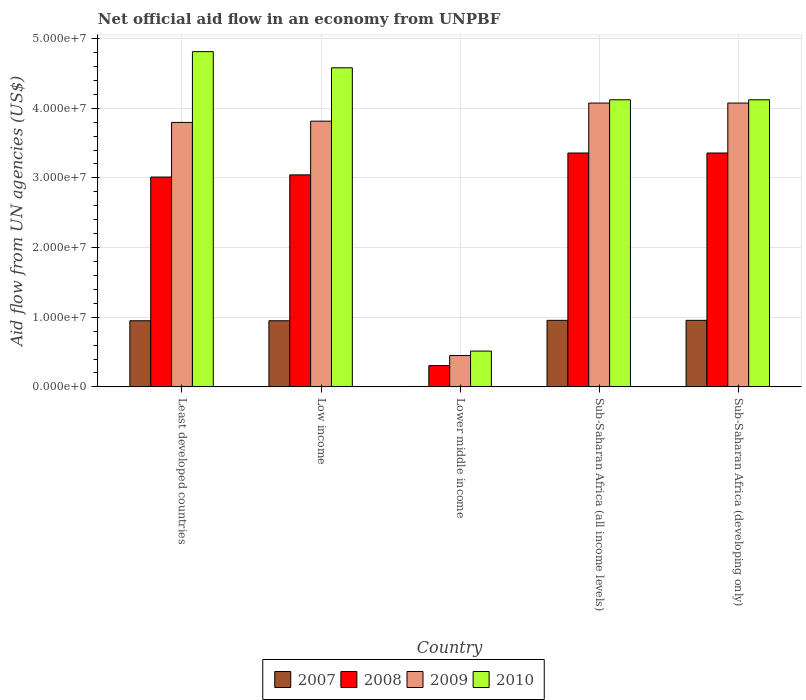How many groups of bars are there?
Keep it short and to the point. 5. What is the label of the 5th group of bars from the left?
Offer a very short reply. Sub-Saharan Africa (developing only). In how many cases, is the number of bars for a given country not equal to the number of legend labels?
Your response must be concise. 0. What is the net official aid flow in 2008 in Lower middle income?
Provide a short and direct response. 3.05e+06. Across all countries, what is the maximum net official aid flow in 2010?
Ensure brevity in your answer.  4.81e+07. Across all countries, what is the minimum net official aid flow in 2009?
Keep it short and to the point. 4.50e+06. In which country was the net official aid flow in 2007 maximum?
Offer a very short reply. Sub-Saharan Africa (all income levels). In which country was the net official aid flow in 2008 minimum?
Provide a succinct answer. Lower middle income. What is the total net official aid flow in 2009 in the graph?
Your answer should be compact. 1.62e+08. What is the difference between the net official aid flow in 2008 in Lower middle income and that in Sub-Saharan Africa (developing only)?
Your answer should be compact. -3.05e+07. What is the difference between the net official aid flow in 2007 in Low income and the net official aid flow in 2009 in Least developed countries?
Your answer should be compact. -2.85e+07. What is the average net official aid flow in 2008 per country?
Provide a succinct answer. 2.61e+07. What is the difference between the net official aid flow of/in 2010 and net official aid flow of/in 2009 in Least developed countries?
Make the answer very short. 1.02e+07. In how many countries, is the net official aid flow in 2009 greater than 26000000 US$?
Your answer should be compact. 4. What is the ratio of the net official aid flow in 2009 in Lower middle income to that in Sub-Saharan Africa (developing only)?
Give a very brief answer. 0.11. Is the difference between the net official aid flow in 2010 in Lower middle income and Sub-Saharan Africa (developing only) greater than the difference between the net official aid flow in 2009 in Lower middle income and Sub-Saharan Africa (developing only)?
Offer a very short reply. Yes. What is the difference between the highest and the second highest net official aid flow in 2008?
Keep it short and to the point. 3.14e+06. What is the difference between the highest and the lowest net official aid flow in 2010?
Offer a very short reply. 4.30e+07. In how many countries, is the net official aid flow in 2007 greater than the average net official aid flow in 2007 taken over all countries?
Offer a terse response. 4. What does the 2nd bar from the right in Low income represents?
Keep it short and to the point. 2009. What is the difference between two consecutive major ticks on the Y-axis?
Offer a very short reply. 1.00e+07. Does the graph contain any zero values?
Make the answer very short. No. How are the legend labels stacked?
Your response must be concise. Horizontal. What is the title of the graph?
Your response must be concise. Net official aid flow in an economy from UNPBF. What is the label or title of the Y-axis?
Ensure brevity in your answer.  Aid flow from UN agencies (US$). What is the Aid flow from UN agencies (US$) in 2007 in Least developed countries?
Give a very brief answer. 9.49e+06. What is the Aid flow from UN agencies (US$) in 2008 in Least developed countries?
Keep it short and to the point. 3.01e+07. What is the Aid flow from UN agencies (US$) in 2009 in Least developed countries?
Make the answer very short. 3.80e+07. What is the Aid flow from UN agencies (US$) in 2010 in Least developed countries?
Provide a short and direct response. 4.81e+07. What is the Aid flow from UN agencies (US$) in 2007 in Low income?
Your response must be concise. 9.49e+06. What is the Aid flow from UN agencies (US$) in 2008 in Low income?
Keep it short and to the point. 3.04e+07. What is the Aid flow from UN agencies (US$) of 2009 in Low income?
Offer a terse response. 3.81e+07. What is the Aid flow from UN agencies (US$) of 2010 in Low income?
Your answer should be very brief. 4.58e+07. What is the Aid flow from UN agencies (US$) of 2007 in Lower middle income?
Offer a very short reply. 6.00e+04. What is the Aid flow from UN agencies (US$) in 2008 in Lower middle income?
Give a very brief answer. 3.05e+06. What is the Aid flow from UN agencies (US$) in 2009 in Lower middle income?
Provide a succinct answer. 4.50e+06. What is the Aid flow from UN agencies (US$) in 2010 in Lower middle income?
Your response must be concise. 5.14e+06. What is the Aid flow from UN agencies (US$) in 2007 in Sub-Saharan Africa (all income levels)?
Ensure brevity in your answer.  9.55e+06. What is the Aid flow from UN agencies (US$) of 2008 in Sub-Saharan Africa (all income levels)?
Offer a terse response. 3.36e+07. What is the Aid flow from UN agencies (US$) of 2009 in Sub-Saharan Africa (all income levels)?
Make the answer very short. 4.07e+07. What is the Aid flow from UN agencies (US$) of 2010 in Sub-Saharan Africa (all income levels)?
Offer a terse response. 4.12e+07. What is the Aid flow from UN agencies (US$) of 2007 in Sub-Saharan Africa (developing only)?
Your response must be concise. 9.55e+06. What is the Aid flow from UN agencies (US$) in 2008 in Sub-Saharan Africa (developing only)?
Ensure brevity in your answer.  3.36e+07. What is the Aid flow from UN agencies (US$) in 2009 in Sub-Saharan Africa (developing only)?
Offer a terse response. 4.07e+07. What is the Aid flow from UN agencies (US$) of 2010 in Sub-Saharan Africa (developing only)?
Your answer should be compact. 4.12e+07. Across all countries, what is the maximum Aid flow from UN agencies (US$) of 2007?
Offer a terse response. 9.55e+06. Across all countries, what is the maximum Aid flow from UN agencies (US$) in 2008?
Make the answer very short. 3.36e+07. Across all countries, what is the maximum Aid flow from UN agencies (US$) of 2009?
Offer a terse response. 4.07e+07. Across all countries, what is the maximum Aid flow from UN agencies (US$) in 2010?
Make the answer very short. 4.81e+07. Across all countries, what is the minimum Aid flow from UN agencies (US$) of 2008?
Provide a succinct answer. 3.05e+06. Across all countries, what is the minimum Aid flow from UN agencies (US$) in 2009?
Provide a short and direct response. 4.50e+06. Across all countries, what is the minimum Aid flow from UN agencies (US$) of 2010?
Your response must be concise. 5.14e+06. What is the total Aid flow from UN agencies (US$) in 2007 in the graph?
Make the answer very short. 3.81e+07. What is the total Aid flow from UN agencies (US$) in 2008 in the graph?
Offer a very short reply. 1.31e+08. What is the total Aid flow from UN agencies (US$) in 2009 in the graph?
Offer a very short reply. 1.62e+08. What is the total Aid flow from UN agencies (US$) of 2010 in the graph?
Give a very brief answer. 1.81e+08. What is the difference between the Aid flow from UN agencies (US$) of 2007 in Least developed countries and that in Low income?
Your answer should be very brief. 0. What is the difference between the Aid flow from UN agencies (US$) in 2008 in Least developed countries and that in Low income?
Your answer should be very brief. -3.10e+05. What is the difference between the Aid flow from UN agencies (US$) in 2010 in Least developed countries and that in Low income?
Offer a very short reply. 2.32e+06. What is the difference between the Aid flow from UN agencies (US$) of 2007 in Least developed countries and that in Lower middle income?
Offer a very short reply. 9.43e+06. What is the difference between the Aid flow from UN agencies (US$) in 2008 in Least developed countries and that in Lower middle income?
Provide a succinct answer. 2.71e+07. What is the difference between the Aid flow from UN agencies (US$) in 2009 in Least developed countries and that in Lower middle income?
Your answer should be very brief. 3.35e+07. What is the difference between the Aid flow from UN agencies (US$) in 2010 in Least developed countries and that in Lower middle income?
Your answer should be very brief. 4.30e+07. What is the difference between the Aid flow from UN agencies (US$) in 2008 in Least developed countries and that in Sub-Saharan Africa (all income levels)?
Provide a short and direct response. -3.45e+06. What is the difference between the Aid flow from UN agencies (US$) in 2009 in Least developed countries and that in Sub-Saharan Africa (all income levels)?
Provide a short and direct response. -2.78e+06. What is the difference between the Aid flow from UN agencies (US$) of 2010 in Least developed countries and that in Sub-Saharan Africa (all income levels)?
Offer a terse response. 6.91e+06. What is the difference between the Aid flow from UN agencies (US$) of 2007 in Least developed countries and that in Sub-Saharan Africa (developing only)?
Keep it short and to the point. -6.00e+04. What is the difference between the Aid flow from UN agencies (US$) in 2008 in Least developed countries and that in Sub-Saharan Africa (developing only)?
Ensure brevity in your answer.  -3.45e+06. What is the difference between the Aid flow from UN agencies (US$) of 2009 in Least developed countries and that in Sub-Saharan Africa (developing only)?
Keep it short and to the point. -2.78e+06. What is the difference between the Aid flow from UN agencies (US$) in 2010 in Least developed countries and that in Sub-Saharan Africa (developing only)?
Your response must be concise. 6.91e+06. What is the difference between the Aid flow from UN agencies (US$) of 2007 in Low income and that in Lower middle income?
Give a very brief answer. 9.43e+06. What is the difference between the Aid flow from UN agencies (US$) in 2008 in Low income and that in Lower middle income?
Your response must be concise. 2.74e+07. What is the difference between the Aid flow from UN agencies (US$) in 2009 in Low income and that in Lower middle income?
Ensure brevity in your answer.  3.36e+07. What is the difference between the Aid flow from UN agencies (US$) in 2010 in Low income and that in Lower middle income?
Provide a succinct answer. 4.07e+07. What is the difference between the Aid flow from UN agencies (US$) of 2008 in Low income and that in Sub-Saharan Africa (all income levels)?
Your answer should be compact. -3.14e+06. What is the difference between the Aid flow from UN agencies (US$) of 2009 in Low income and that in Sub-Saharan Africa (all income levels)?
Keep it short and to the point. -2.60e+06. What is the difference between the Aid flow from UN agencies (US$) of 2010 in Low income and that in Sub-Saharan Africa (all income levels)?
Your answer should be very brief. 4.59e+06. What is the difference between the Aid flow from UN agencies (US$) in 2007 in Low income and that in Sub-Saharan Africa (developing only)?
Ensure brevity in your answer.  -6.00e+04. What is the difference between the Aid flow from UN agencies (US$) in 2008 in Low income and that in Sub-Saharan Africa (developing only)?
Provide a succinct answer. -3.14e+06. What is the difference between the Aid flow from UN agencies (US$) of 2009 in Low income and that in Sub-Saharan Africa (developing only)?
Offer a terse response. -2.60e+06. What is the difference between the Aid flow from UN agencies (US$) of 2010 in Low income and that in Sub-Saharan Africa (developing only)?
Your response must be concise. 4.59e+06. What is the difference between the Aid flow from UN agencies (US$) of 2007 in Lower middle income and that in Sub-Saharan Africa (all income levels)?
Provide a succinct answer. -9.49e+06. What is the difference between the Aid flow from UN agencies (US$) of 2008 in Lower middle income and that in Sub-Saharan Africa (all income levels)?
Offer a very short reply. -3.05e+07. What is the difference between the Aid flow from UN agencies (US$) of 2009 in Lower middle income and that in Sub-Saharan Africa (all income levels)?
Give a very brief answer. -3.62e+07. What is the difference between the Aid flow from UN agencies (US$) in 2010 in Lower middle income and that in Sub-Saharan Africa (all income levels)?
Offer a terse response. -3.61e+07. What is the difference between the Aid flow from UN agencies (US$) in 2007 in Lower middle income and that in Sub-Saharan Africa (developing only)?
Provide a short and direct response. -9.49e+06. What is the difference between the Aid flow from UN agencies (US$) in 2008 in Lower middle income and that in Sub-Saharan Africa (developing only)?
Your answer should be compact. -3.05e+07. What is the difference between the Aid flow from UN agencies (US$) of 2009 in Lower middle income and that in Sub-Saharan Africa (developing only)?
Provide a short and direct response. -3.62e+07. What is the difference between the Aid flow from UN agencies (US$) in 2010 in Lower middle income and that in Sub-Saharan Africa (developing only)?
Make the answer very short. -3.61e+07. What is the difference between the Aid flow from UN agencies (US$) in 2007 in Sub-Saharan Africa (all income levels) and that in Sub-Saharan Africa (developing only)?
Offer a terse response. 0. What is the difference between the Aid flow from UN agencies (US$) in 2008 in Sub-Saharan Africa (all income levels) and that in Sub-Saharan Africa (developing only)?
Offer a terse response. 0. What is the difference between the Aid flow from UN agencies (US$) in 2010 in Sub-Saharan Africa (all income levels) and that in Sub-Saharan Africa (developing only)?
Give a very brief answer. 0. What is the difference between the Aid flow from UN agencies (US$) in 2007 in Least developed countries and the Aid flow from UN agencies (US$) in 2008 in Low income?
Your response must be concise. -2.09e+07. What is the difference between the Aid flow from UN agencies (US$) in 2007 in Least developed countries and the Aid flow from UN agencies (US$) in 2009 in Low income?
Keep it short and to the point. -2.86e+07. What is the difference between the Aid flow from UN agencies (US$) in 2007 in Least developed countries and the Aid flow from UN agencies (US$) in 2010 in Low income?
Provide a short and direct response. -3.63e+07. What is the difference between the Aid flow from UN agencies (US$) in 2008 in Least developed countries and the Aid flow from UN agencies (US$) in 2009 in Low income?
Make the answer very short. -8.02e+06. What is the difference between the Aid flow from UN agencies (US$) of 2008 in Least developed countries and the Aid flow from UN agencies (US$) of 2010 in Low income?
Offer a terse response. -1.57e+07. What is the difference between the Aid flow from UN agencies (US$) of 2009 in Least developed countries and the Aid flow from UN agencies (US$) of 2010 in Low income?
Offer a very short reply. -7.84e+06. What is the difference between the Aid flow from UN agencies (US$) in 2007 in Least developed countries and the Aid flow from UN agencies (US$) in 2008 in Lower middle income?
Provide a short and direct response. 6.44e+06. What is the difference between the Aid flow from UN agencies (US$) in 2007 in Least developed countries and the Aid flow from UN agencies (US$) in 2009 in Lower middle income?
Your response must be concise. 4.99e+06. What is the difference between the Aid flow from UN agencies (US$) of 2007 in Least developed countries and the Aid flow from UN agencies (US$) of 2010 in Lower middle income?
Give a very brief answer. 4.35e+06. What is the difference between the Aid flow from UN agencies (US$) in 2008 in Least developed countries and the Aid flow from UN agencies (US$) in 2009 in Lower middle income?
Make the answer very short. 2.56e+07. What is the difference between the Aid flow from UN agencies (US$) of 2008 in Least developed countries and the Aid flow from UN agencies (US$) of 2010 in Lower middle income?
Make the answer very short. 2.50e+07. What is the difference between the Aid flow from UN agencies (US$) in 2009 in Least developed countries and the Aid flow from UN agencies (US$) in 2010 in Lower middle income?
Your answer should be compact. 3.28e+07. What is the difference between the Aid flow from UN agencies (US$) in 2007 in Least developed countries and the Aid flow from UN agencies (US$) in 2008 in Sub-Saharan Africa (all income levels)?
Offer a very short reply. -2.41e+07. What is the difference between the Aid flow from UN agencies (US$) in 2007 in Least developed countries and the Aid flow from UN agencies (US$) in 2009 in Sub-Saharan Africa (all income levels)?
Keep it short and to the point. -3.12e+07. What is the difference between the Aid flow from UN agencies (US$) in 2007 in Least developed countries and the Aid flow from UN agencies (US$) in 2010 in Sub-Saharan Africa (all income levels)?
Provide a succinct answer. -3.17e+07. What is the difference between the Aid flow from UN agencies (US$) in 2008 in Least developed countries and the Aid flow from UN agencies (US$) in 2009 in Sub-Saharan Africa (all income levels)?
Keep it short and to the point. -1.06e+07. What is the difference between the Aid flow from UN agencies (US$) in 2008 in Least developed countries and the Aid flow from UN agencies (US$) in 2010 in Sub-Saharan Africa (all income levels)?
Give a very brief answer. -1.11e+07. What is the difference between the Aid flow from UN agencies (US$) in 2009 in Least developed countries and the Aid flow from UN agencies (US$) in 2010 in Sub-Saharan Africa (all income levels)?
Keep it short and to the point. -3.25e+06. What is the difference between the Aid flow from UN agencies (US$) in 2007 in Least developed countries and the Aid flow from UN agencies (US$) in 2008 in Sub-Saharan Africa (developing only)?
Make the answer very short. -2.41e+07. What is the difference between the Aid flow from UN agencies (US$) in 2007 in Least developed countries and the Aid flow from UN agencies (US$) in 2009 in Sub-Saharan Africa (developing only)?
Your answer should be compact. -3.12e+07. What is the difference between the Aid flow from UN agencies (US$) in 2007 in Least developed countries and the Aid flow from UN agencies (US$) in 2010 in Sub-Saharan Africa (developing only)?
Give a very brief answer. -3.17e+07. What is the difference between the Aid flow from UN agencies (US$) of 2008 in Least developed countries and the Aid flow from UN agencies (US$) of 2009 in Sub-Saharan Africa (developing only)?
Make the answer very short. -1.06e+07. What is the difference between the Aid flow from UN agencies (US$) in 2008 in Least developed countries and the Aid flow from UN agencies (US$) in 2010 in Sub-Saharan Africa (developing only)?
Keep it short and to the point. -1.11e+07. What is the difference between the Aid flow from UN agencies (US$) of 2009 in Least developed countries and the Aid flow from UN agencies (US$) of 2010 in Sub-Saharan Africa (developing only)?
Give a very brief answer. -3.25e+06. What is the difference between the Aid flow from UN agencies (US$) in 2007 in Low income and the Aid flow from UN agencies (US$) in 2008 in Lower middle income?
Keep it short and to the point. 6.44e+06. What is the difference between the Aid flow from UN agencies (US$) of 2007 in Low income and the Aid flow from UN agencies (US$) of 2009 in Lower middle income?
Give a very brief answer. 4.99e+06. What is the difference between the Aid flow from UN agencies (US$) of 2007 in Low income and the Aid flow from UN agencies (US$) of 2010 in Lower middle income?
Make the answer very short. 4.35e+06. What is the difference between the Aid flow from UN agencies (US$) of 2008 in Low income and the Aid flow from UN agencies (US$) of 2009 in Lower middle income?
Ensure brevity in your answer.  2.59e+07. What is the difference between the Aid flow from UN agencies (US$) in 2008 in Low income and the Aid flow from UN agencies (US$) in 2010 in Lower middle income?
Make the answer very short. 2.53e+07. What is the difference between the Aid flow from UN agencies (US$) of 2009 in Low income and the Aid flow from UN agencies (US$) of 2010 in Lower middle income?
Provide a succinct answer. 3.30e+07. What is the difference between the Aid flow from UN agencies (US$) in 2007 in Low income and the Aid flow from UN agencies (US$) in 2008 in Sub-Saharan Africa (all income levels)?
Provide a succinct answer. -2.41e+07. What is the difference between the Aid flow from UN agencies (US$) in 2007 in Low income and the Aid flow from UN agencies (US$) in 2009 in Sub-Saharan Africa (all income levels)?
Your response must be concise. -3.12e+07. What is the difference between the Aid flow from UN agencies (US$) of 2007 in Low income and the Aid flow from UN agencies (US$) of 2010 in Sub-Saharan Africa (all income levels)?
Ensure brevity in your answer.  -3.17e+07. What is the difference between the Aid flow from UN agencies (US$) of 2008 in Low income and the Aid flow from UN agencies (US$) of 2009 in Sub-Saharan Africa (all income levels)?
Ensure brevity in your answer.  -1.03e+07. What is the difference between the Aid flow from UN agencies (US$) in 2008 in Low income and the Aid flow from UN agencies (US$) in 2010 in Sub-Saharan Africa (all income levels)?
Provide a succinct answer. -1.08e+07. What is the difference between the Aid flow from UN agencies (US$) in 2009 in Low income and the Aid flow from UN agencies (US$) in 2010 in Sub-Saharan Africa (all income levels)?
Make the answer very short. -3.07e+06. What is the difference between the Aid flow from UN agencies (US$) of 2007 in Low income and the Aid flow from UN agencies (US$) of 2008 in Sub-Saharan Africa (developing only)?
Provide a short and direct response. -2.41e+07. What is the difference between the Aid flow from UN agencies (US$) in 2007 in Low income and the Aid flow from UN agencies (US$) in 2009 in Sub-Saharan Africa (developing only)?
Keep it short and to the point. -3.12e+07. What is the difference between the Aid flow from UN agencies (US$) in 2007 in Low income and the Aid flow from UN agencies (US$) in 2010 in Sub-Saharan Africa (developing only)?
Provide a succinct answer. -3.17e+07. What is the difference between the Aid flow from UN agencies (US$) in 2008 in Low income and the Aid flow from UN agencies (US$) in 2009 in Sub-Saharan Africa (developing only)?
Offer a terse response. -1.03e+07. What is the difference between the Aid flow from UN agencies (US$) in 2008 in Low income and the Aid flow from UN agencies (US$) in 2010 in Sub-Saharan Africa (developing only)?
Provide a short and direct response. -1.08e+07. What is the difference between the Aid flow from UN agencies (US$) in 2009 in Low income and the Aid flow from UN agencies (US$) in 2010 in Sub-Saharan Africa (developing only)?
Ensure brevity in your answer.  -3.07e+06. What is the difference between the Aid flow from UN agencies (US$) of 2007 in Lower middle income and the Aid flow from UN agencies (US$) of 2008 in Sub-Saharan Africa (all income levels)?
Ensure brevity in your answer.  -3.35e+07. What is the difference between the Aid flow from UN agencies (US$) of 2007 in Lower middle income and the Aid flow from UN agencies (US$) of 2009 in Sub-Saharan Africa (all income levels)?
Keep it short and to the point. -4.07e+07. What is the difference between the Aid flow from UN agencies (US$) in 2007 in Lower middle income and the Aid flow from UN agencies (US$) in 2010 in Sub-Saharan Africa (all income levels)?
Your response must be concise. -4.12e+07. What is the difference between the Aid flow from UN agencies (US$) in 2008 in Lower middle income and the Aid flow from UN agencies (US$) in 2009 in Sub-Saharan Africa (all income levels)?
Offer a terse response. -3.77e+07. What is the difference between the Aid flow from UN agencies (US$) in 2008 in Lower middle income and the Aid flow from UN agencies (US$) in 2010 in Sub-Saharan Africa (all income levels)?
Provide a succinct answer. -3.82e+07. What is the difference between the Aid flow from UN agencies (US$) in 2009 in Lower middle income and the Aid flow from UN agencies (US$) in 2010 in Sub-Saharan Africa (all income levels)?
Your answer should be very brief. -3.67e+07. What is the difference between the Aid flow from UN agencies (US$) of 2007 in Lower middle income and the Aid flow from UN agencies (US$) of 2008 in Sub-Saharan Africa (developing only)?
Give a very brief answer. -3.35e+07. What is the difference between the Aid flow from UN agencies (US$) in 2007 in Lower middle income and the Aid flow from UN agencies (US$) in 2009 in Sub-Saharan Africa (developing only)?
Your answer should be compact. -4.07e+07. What is the difference between the Aid flow from UN agencies (US$) of 2007 in Lower middle income and the Aid flow from UN agencies (US$) of 2010 in Sub-Saharan Africa (developing only)?
Your answer should be very brief. -4.12e+07. What is the difference between the Aid flow from UN agencies (US$) in 2008 in Lower middle income and the Aid flow from UN agencies (US$) in 2009 in Sub-Saharan Africa (developing only)?
Make the answer very short. -3.77e+07. What is the difference between the Aid flow from UN agencies (US$) in 2008 in Lower middle income and the Aid flow from UN agencies (US$) in 2010 in Sub-Saharan Africa (developing only)?
Make the answer very short. -3.82e+07. What is the difference between the Aid flow from UN agencies (US$) of 2009 in Lower middle income and the Aid flow from UN agencies (US$) of 2010 in Sub-Saharan Africa (developing only)?
Your answer should be compact. -3.67e+07. What is the difference between the Aid flow from UN agencies (US$) in 2007 in Sub-Saharan Africa (all income levels) and the Aid flow from UN agencies (US$) in 2008 in Sub-Saharan Africa (developing only)?
Keep it short and to the point. -2.40e+07. What is the difference between the Aid flow from UN agencies (US$) of 2007 in Sub-Saharan Africa (all income levels) and the Aid flow from UN agencies (US$) of 2009 in Sub-Saharan Africa (developing only)?
Make the answer very short. -3.12e+07. What is the difference between the Aid flow from UN agencies (US$) of 2007 in Sub-Saharan Africa (all income levels) and the Aid flow from UN agencies (US$) of 2010 in Sub-Saharan Africa (developing only)?
Ensure brevity in your answer.  -3.17e+07. What is the difference between the Aid flow from UN agencies (US$) of 2008 in Sub-Saharan Africa (all income levels) and the Aid flow from UN agencies (US$) of 2009 in Sub-Saharan Africa (developing only)?
Provide a short and direct response. -7.17e+06. What is the difference between the Aid flow from UN agencies (US$) of 2008 in Sub-Saharan Africa (all income levels) and the Aid flow from UN agencies (US$) of 2010 in Sub-Saharan Africa (developing only)?
Your answer should be compact. -7.64e+06. What is the difference between the Aid flow from UN agencies (US$) in 2009 in Sub-Saharan Africa (all income levels) and the Aid flow from UN agencies (US$) in 2010 in Sub-Saharan Africa (developing only)?
Your response must be concise. -4.70e+05. What is the average Aid flow from UN agencies (US$) in 2007 per country?
Ensure brevity in your answer.  7.63e+06. What is the average Aid flow from UN agencies (US$) in 2008 per country?
Make the answer very short. 2.61e+07. What is the average Aid flow from UN agencies (US$) of 2009 per country?
Ensure brevity in your answer.  3.24e+07. What is the average Aid flow from UN agencies (US$) of 2010 per country?
Offer a very short reply. 3.63e+07. What is the difference between the Aid flow from UN agencies (US$) in 2007 and Aid flow from UN agencies (US$) in 2008 in Least developed countries?
Your answer should be very brief. -2.06e+07. What is the difference between the Aid flow from UN agencies (US$) of 2007 and Aid flow from UN agencies (US$) of 2009 in Least developed countries?
Make the answer very short. -2.85e+07. What is the difference between the Aid flow from UN agencies (US$) in 2007 and Aid flow from UN agencies (US$) in 2010 in Least developed countries?
Provide a short and direct response. -3.86e+07. What is the difference between the Aid flow from UN agencies (US$) in 2008 and Aid flow from UN agencies (US$) in 2009 in Least developed countries?
Your answer should be compact. -7.84e+06. What is the difference between the Aid flow from UN agencies (US$) of 2008 and Aid flow from UN agencies (US$) of 2010 in Least developed countries?
Provide a succinct answer. -1.80e+07. What is the difference between the Aid flow from UN agencies (US$) in 2009 and Aid flow from UN agencies (US$) in 2010 in Least developed countries?
Your answer should be compact. -1.02e+07. What is the difference between the Aid flow from UN agencies (US$) in 2007 and Aid flow from UN agencies (US$) in 2008 in Low income?
Your response must be concise. -2.09e+07. What is the difference between the Aid flow from UN agencies (US$) in 2007 and Aid flow from UN agencies (US$) in 2009 in Low income?
Provide a short and direct response. -2.86e+07. What is the difference between the Aid flow from UN agencies (US$) of 2007 and Aid flow from UN agencies (US$) of 2010 in Low income?
Your response must be concise. -3.63e+07. What is the difference between the Aid flow from UN agencies (US$) of 2008 and Aid flow from UN agencies (US$) of 2009 in Low income?
Provide a short and direct response. -7.71e+06. What is the difference between the Aid flow from UN agencies (US$) in 2008 and Aid flow from UN agencies (US$) in 2010 in Low income?
Ensure brevity in your answer.  -1.54e+07. What is the difference between the Aid flow from UN agencies (US$) of 2009 and Aid flow from UN agencies (US$) of 2010 in Low income?
Offer a terse response. -7.66e+06. What is the difference between the Aid flow from UN agencies (US$) in 2007 and Aid flow from UN agencies (US$) in 2008 in Lower middle income?
Provide a succinct answer. -2.99e+06. What is the difference between the Aid flow from UN agencies (US$) in 2007 and Aid flow from UN agencies (US$) in 2009 in Lower middle income?
Offer a very short reply. -4.44e+06. What is the difference between the Aid flow from UN agencies (US$) of 2007 and Aid flow from UN agencies (US$) of 2010 in Lower middle income?
Make the answer very short. -5.08e+06. What is the difference between the Aid flow from UN agencies (US$) of 2008 and Aid flow from UN agencies (US$) of 2009 in Lower middle income?
Your answer should be compact. -1.45e+06. What is the difference between the Aid flow from UN agencies (US$) of 2008 and Aid flow from UN agencies (US$) of 2010 in Lower middle income?
Ensure brevity in your answer.  -2.09e+06. What is the difference between the Aid flow from UN agencies (US$) in 2009 and Aid flow from UN agencies (US$) in 2010 in Lower middle income?
Offer a terse response. -6.40e+05. What is the difference between the Aid flow from UN agencies (US$) in 2007 and Aid flow from UN agencies (US$) in 2008 in Sub-Saharan Africa (all income levels)?
Your answer should be very brief. -2.40e+07. What is the difference between the Aid flow from UN agencies (US$) in 2007 and Aid flow from UN agencies (US$) in 2009 in Sub-Saharan Africa (all income levels)?
Keep it short and to the point. -3.12e+07. What is the difference between the Aid flow from UN agencies (US$) in 2007 and Aid flow from UN agencies (US$) in 2010 in Sub-Saharan Africa (all income levels)?
Ensure brevity in your answer.  -3.17e+07. What is the difference between the Aid flow from UN agencies (US$) in 2008 and Aid flow from UN agencies (US$) in 2009 in Sub-Saharan Africa (all income levels)?
Give a very brief answer. -7.17e+06. What is the difference between the Aid flow from UN agencies (US$) in 2008 and Aid flow from UN agencies (US$) in 2010 in Sub-Saharan Africa (all income levels)?
Keep it short and to the point. -7.64e+06. What is the difference between the Aid flow from UN agencies (US$) of 2009 and Aid flow from UN agencies (US$) of 2010 in Sub-Saharan Africa (all income levels)?
Make the answer very short. -4.70e+05. What is the difference between the Aid flow from UN agencies (US$) in 2007 and Aid flow from UN agencies (US$) in 2008 in Sub-Saharan Africa (developing only)?
Give a very brief answer. -2.40e+07. What is the difference between the Aid flow from UN agencies (US$) in 2007 and Aid flow from UN agencies (US$) in 2009 in Sub-Saharan Africa (developing only)?
Ensure brevity in your answer.  -3.12e+07. What is the difference between the Aid flow from UN agencies (US$) of 2007 and Aid flow from UN agencies (US$) of 2010 in Sub-Saharan Africa (developing only)?
Offer a terse response. -3.17e+07. What is the difference between the Aid flow from UN agencies (US$) of 2008 and Aid flow from UN agencies (US$) of 2009 in Sub-Saharan Africa (developing only)?
Your response must be concise. -7.17e+06. What is the difference between the Aid flow from UN agencies (US$) of 2008 and Aid flow from UN agencies (US$) of 2010 in Sub-Saharan Africa (developing only)?
Keep it short and to the point. -7.64e+06. What is the difference between the Aid flow from UN agencies (US$) of 2009 and Aid flow from UN agencies (US$) of 2010 in Sub-Saharan Africa (developing only)?
Give a very brief answer. -4.70e+05. What is the ratio of the Aid flow from UN agencies (US$) of 2007 in Least developed countries to that in Low income?
Provide a short and direct response. 1. What is the ratio of the Aid flow from UN agencies (US$) of 2009 in Least developed countries to that in Low income?
Offer a very short reply. 1. What is the ratio of the Aid flow from UN agencies (US$) of 2010 in Least developed countries to that in Low income?
Your answer should be compact. 1.05. What is the ratio of the Aid flow from UN agencies (US$) of 2007 in Least developed countries to that in Lower middle income?
Provide a short and direct response. 158.17. What is the ratio of the Aid flow from UN agencies (US$) of 2008 in Least developed countries to that in Lower middle income?
Your response must be concise. 9.88. What is the ratio of the Aid flow from UN agencies (US$) of 2009 in Least developed countries to that in Lower middle income?
Ensure brevity in your answer.  8.44. What is the ratio of the Aid flow from UN agencies (US$) of 2010 in Least developed countries to that in Lower middle income?
Keep it short and to the point. 9.36. What is the ratio of the Aid flow from UN agencies (US$) in 2008 in Least developed countries to that in Sub-Saharan Africa (all income levels)?
Ensure brevity in your answer.  0.9. What is the ratio of the Aid flow from UN agencies (US$) of 2009 in Least developed countries to that in Sub-Saharan Africa (all income levels)?
Provide a succinct answer. 0.93. What is the ratio of the Aid flow from UN agencies (US$) of 2010 in Least developed countries to that in Sub-Saharan Africa (all income levels)?
Offer a very short reply. 1.17. What is the ratio of the Aid flow from UN agencies (US$) in 2007 in Least developed countries to that in Sub-Saharan Africa (developing only)?
Give a very brief answer. 0.99. What is the ratio of the Aid flow from UN agencies (US$) in 2008 in Least developed countries to that in Sub-Saharan Africa (developing only)?
Provide a succinct answer. 0.9. What is the ratio of the Aid flow from UN agencies (US$) of 2009 in Least developed countries to that in Sub-Saharan Africa (developing only)?
Your answer should be very brief. 0.93. What is the ratio of the Aid flow from UN agencies (US$) in 2010 in Least developed countries to that in Sub-Saharan Africa (developing only)?
Provide a succinct answer. 1.17. What is the ratio of the Aid flow from UN agencies (US$) in 2007 in Low income to that in Lower middle income?
Your answer should be compact. 158.17. What is the ratio of the Aid flow from UN agencies (US$) of 2008 in Low income to that in Lower middle income?
Ensure brevity in your answer.  9.98. What is the ratio of the Aid flow from UN agencies (US$) in 2009 in Low income to that in Lower middle income?
Your response must be concise. 8.48. What is the ratio of the Aid flow from UN agencies (US$) of 2010 in Low income to that in Lower middle income?
Your answer should be very brief. 8.91. What is the ratio of the Aid flow from UN agencies (US$) in 2008 in Low income to that in Sub-Saharan Africa (all income levels)?
Your response must be concise. 0.91. What is the ratio of the Aid flow from UN agencies (US$) in 2009 in Low income to that in Sub-Saharan Africa (all income levels)?
Provide a short and direct response. 0.94. What is the ratio of the Aid flow from UN agencies (US$) in 2010 in Low income to that in Sub-Saharan Africa (all income levels)?
Provide a short and direct response. 1.11. What is the ratio of the Aid flow from UN agencies (US$) in 2008 in Low income to that in Sub-Saharan Africa (developing only)?
Your answer should be compact. 0.91. What is the ratio of the Aid flow from UN agencies (US$) of 2009 in Low income to that in Sub-Saharan Africa (developing only)?
Provide a succinct answer. 0.94. What is the ratio of the Aid flow from UN agencies (US$) of 2010 in Low income to that in Sub-Saharan Africa (developing only)?
Give a very brief answer. 1.11. What is the ratio of the Aid flow from UN agencies (US$) of 2007 in Lower middle income to that in Sub-Saharan Africa (all income levels)?
Provide a succinct answer. 0.01. What is the ratio of the Aid flow from UN agencies (US$) of 2008 in Lower middle income to that in Sub-Saharan Africa (all income levels)?
Provide a short and direct response. 0.09. What is the ratio of the Aid flow from UN agencies (US$) in 2009 in Lower middle income to that in Sub-Saharan Africa (all income levels)?
Ensure brevity in your answer.  0.11. What is the ratio of the Aid flow from UN agencies (US$) of 2010 in Lower middle income to that in Sub-Saharan Africa (all income levels)?
Your response must be concise. 0.12. What is the ratio of the Aid flow from UN agencies (US$) of 2007 in Lower middle income to that in Sub-Saharan Africa (developing only)?
Your answer should be compact. 0.01. What is the ratio of the Aid flow from UN agencies (US$) in 2008 in Lower middle income to that in Sub-Saharan Africa (developing only)?
Provide a short and direct response. 0.09. What is the ratio of the Aid flow from UN agencies (US$) of 2009 in Lower middle income to that in Sub-Saharan Africa (developing only)?
Make the answer very short. 0.11. What is the ratio of the Aid flow from UN agencies (US$) in 2010 in Lower middle income to that in Sub-Saharan Africa (developing only)?
Make the answer very short. 0.12. What is the ratio of the Aid flow from UN agencies (US$) in 2008 in Sub-Saharan Africa (all income levels) to that in Sub-Saharan Africa (developing only)?
Provide a succinct answer. 1. What is the ratio of the Aid flow from UN agencies (US$) of 2009 in Sub-Saharan Africa (all income levels) to that in Sub-Saharan Africa (developing only)?
Your answer should be compact. 1. What is the difference between the highest and the second highest Aid flow from UN agencies (US$) in 2010?
Ensure brevity in your answer.  2.32e+06. What is the difference between the highest and the lowest Aid flow from UN agencies (US$) of 2007?
Keep it short and to the point. 9.49e+06. What is the difference between the highest and the lowest Aid flow from UN agencies (US$) in 2008?
Provide a succinct answer. 3.05e+07. What is the difference between the highest and the lowest Aid flow from UN agencies (US$) of 2009?
Keep it short and to the point. 3.62e+07. What is the difference between the highest and the lowest Aid flow from UN agencies (US$) of 2010?
Provide a short and direct response. 4.30e+07. 